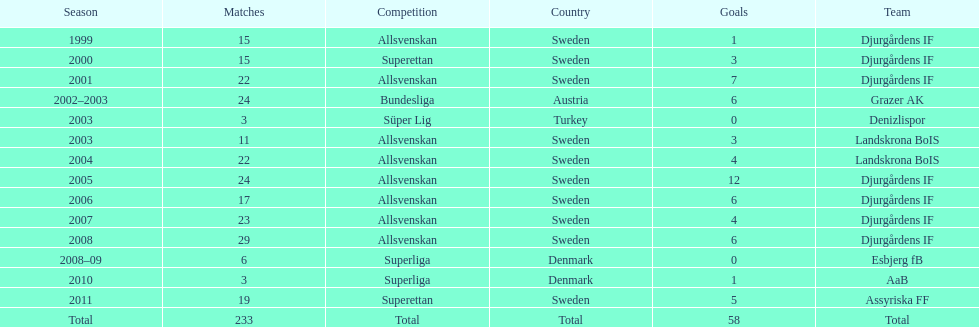From which country does team djurgårdens not originate? Sweden. 